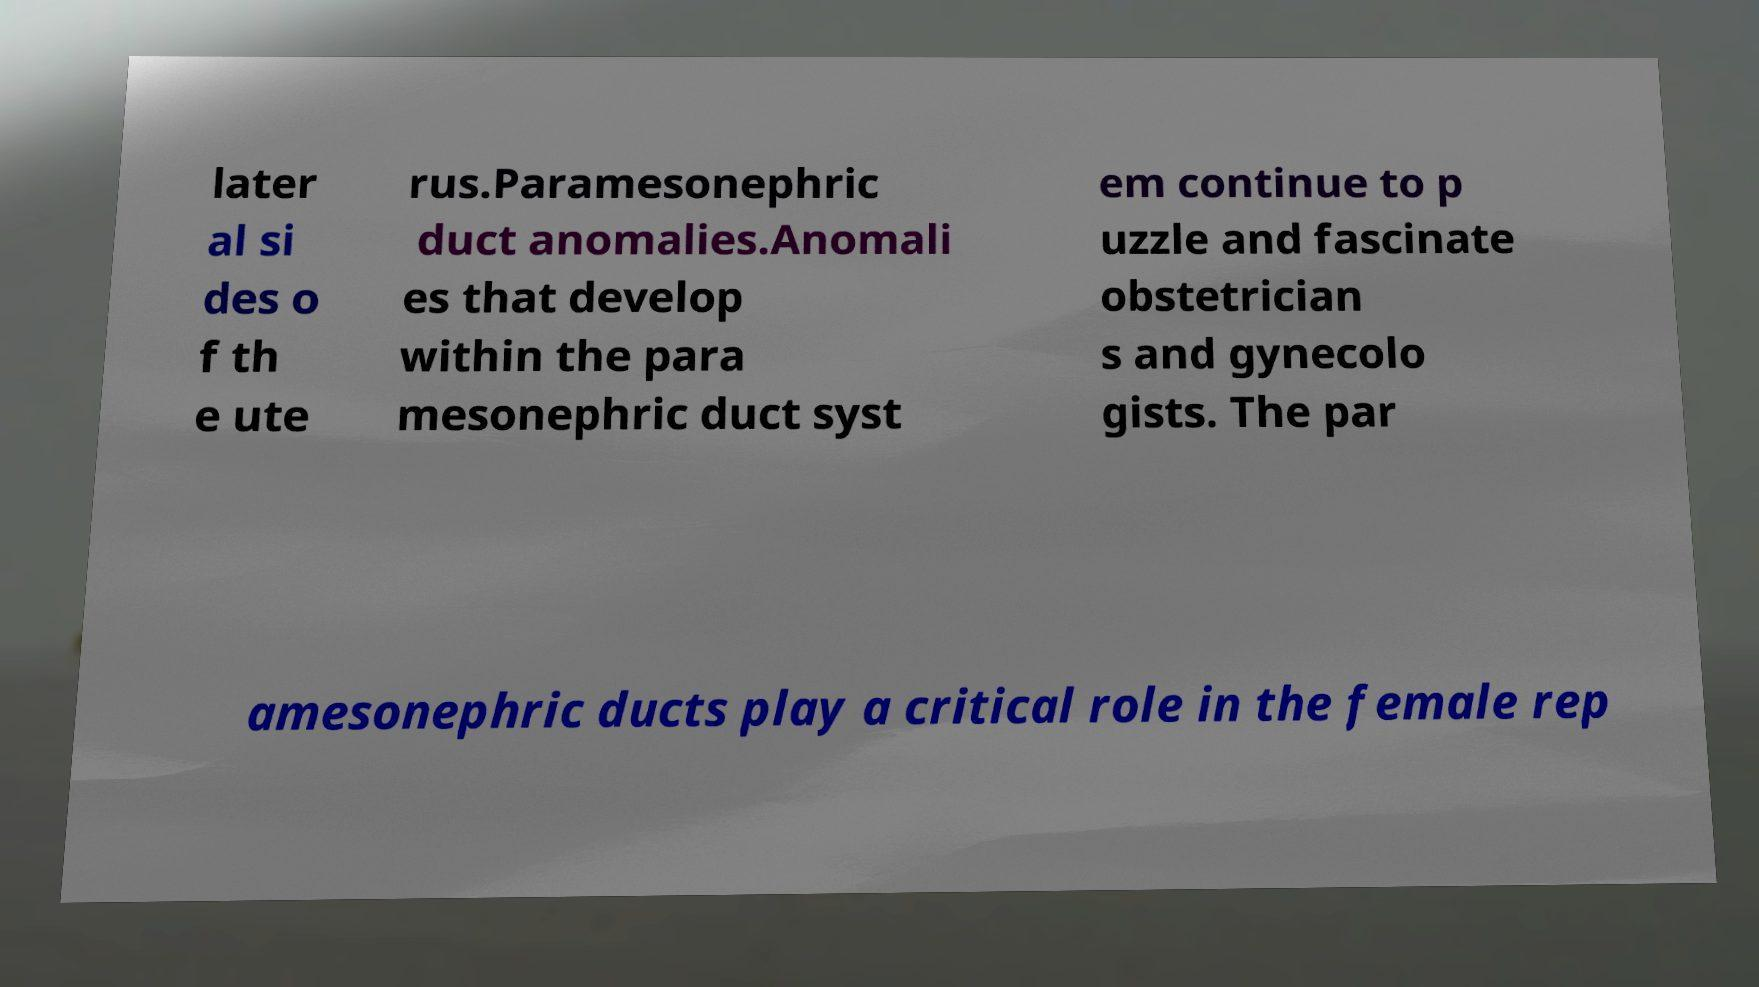Could you assist in decoding the text presented in this image and type it out clearly? later al si des o f th e ute rus.Paramesonephric duct anomalies.Anomali es that develop within the para mesonephric duct syst em continue to p uzzle and fascinate obstetrician s and gynecolo gists. The par amesonephric ducts play a critical role in the female rep 